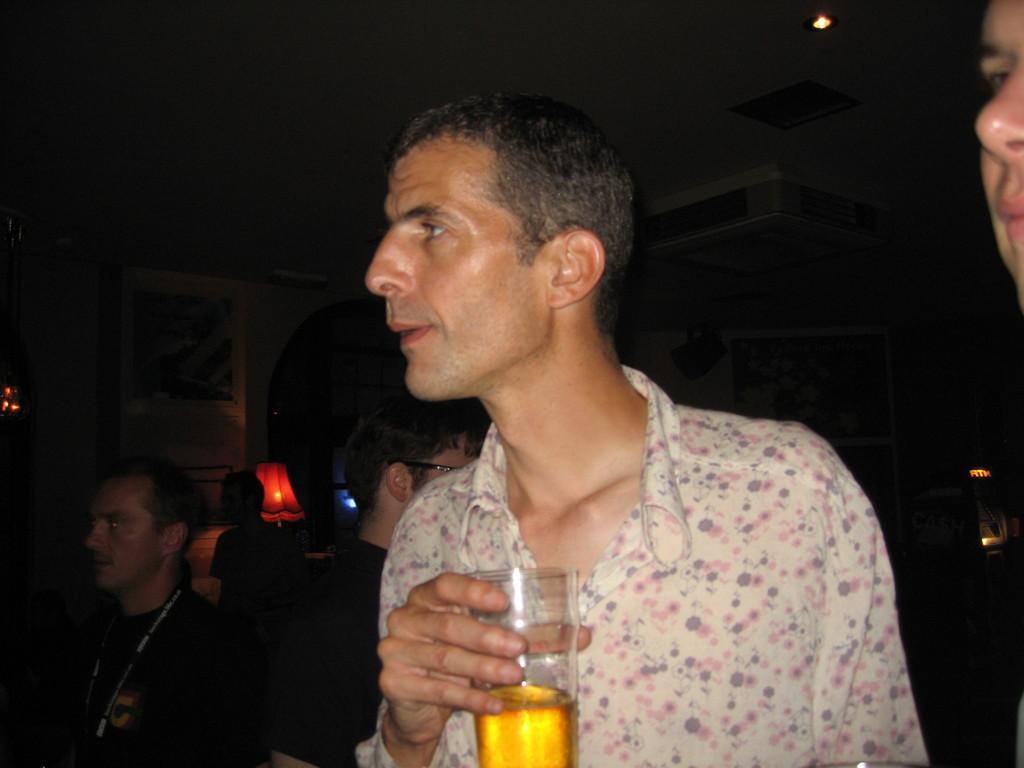Can you describe this image briefly? In this picture we can see a man who is holding a glass with his hand. Even we can see three persons standing here. And this is the wall and there is a lamp. 